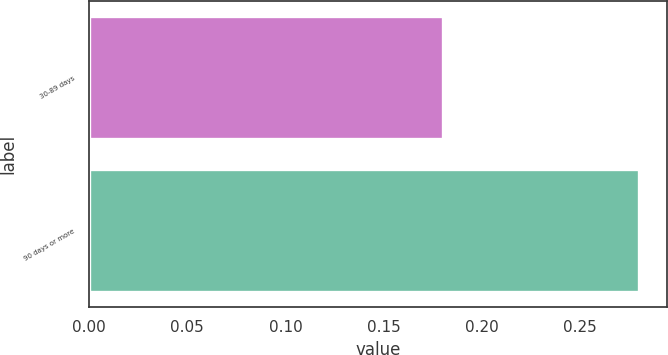<chart> <loc_0><loc_0><loc_500><loc_500><bar_chart><fcel>30-89 days<fcel>90 days or more<nl><fcel>0.18<fcel>0.28<nl></chart> 